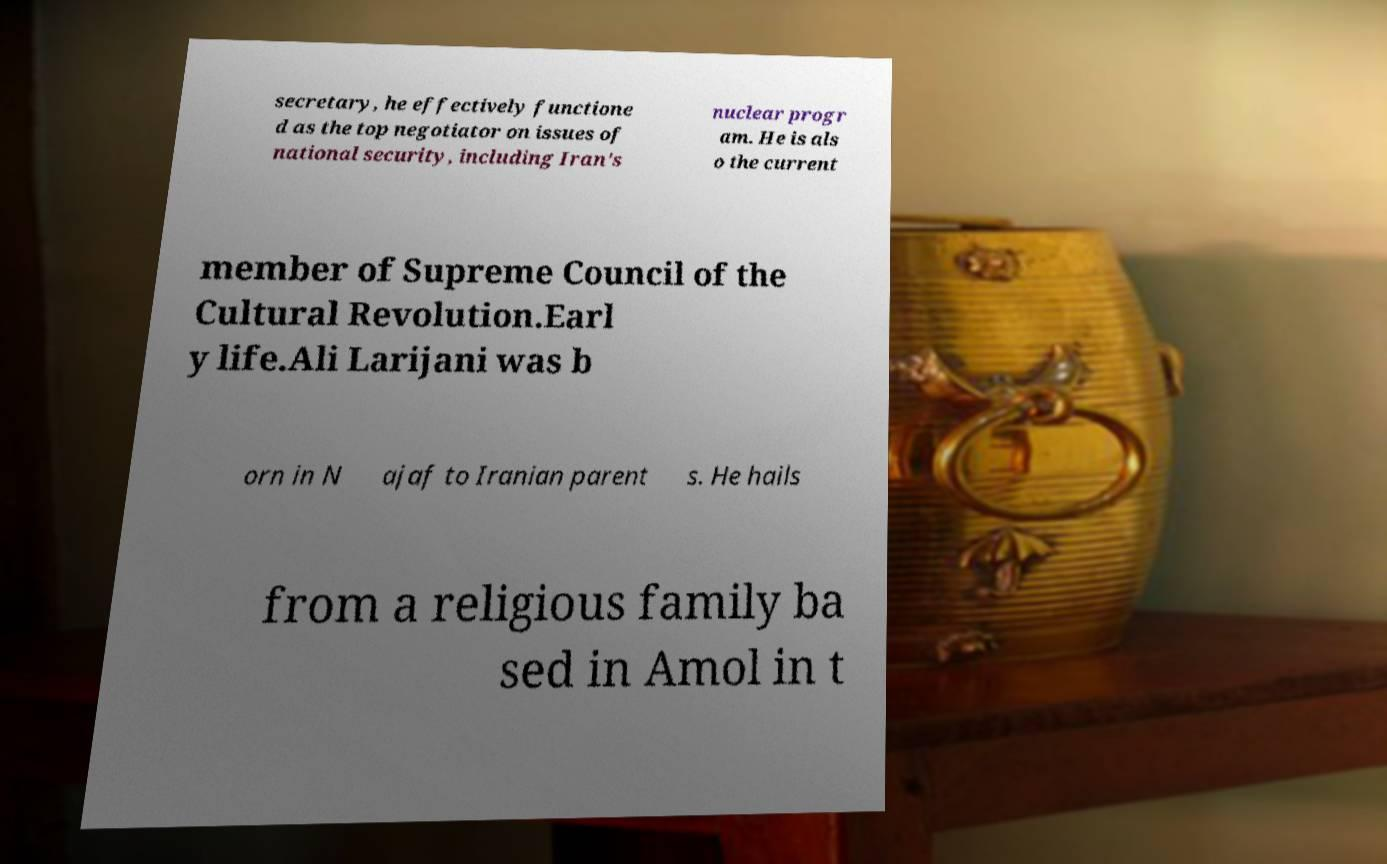What messages or text are displayed in this image? I need them in a readable, typed format. secretary, he effectively functione d as the top negotiator on issues of national security, including Iran's nuclear progr am. He is als o the current member of Supreme Council of the Cultural Revolution.Earl y life.Ali Larijani was b orn in N ajaf to Iranian parent s. He hails from a religious family ba sed in Amol in t 